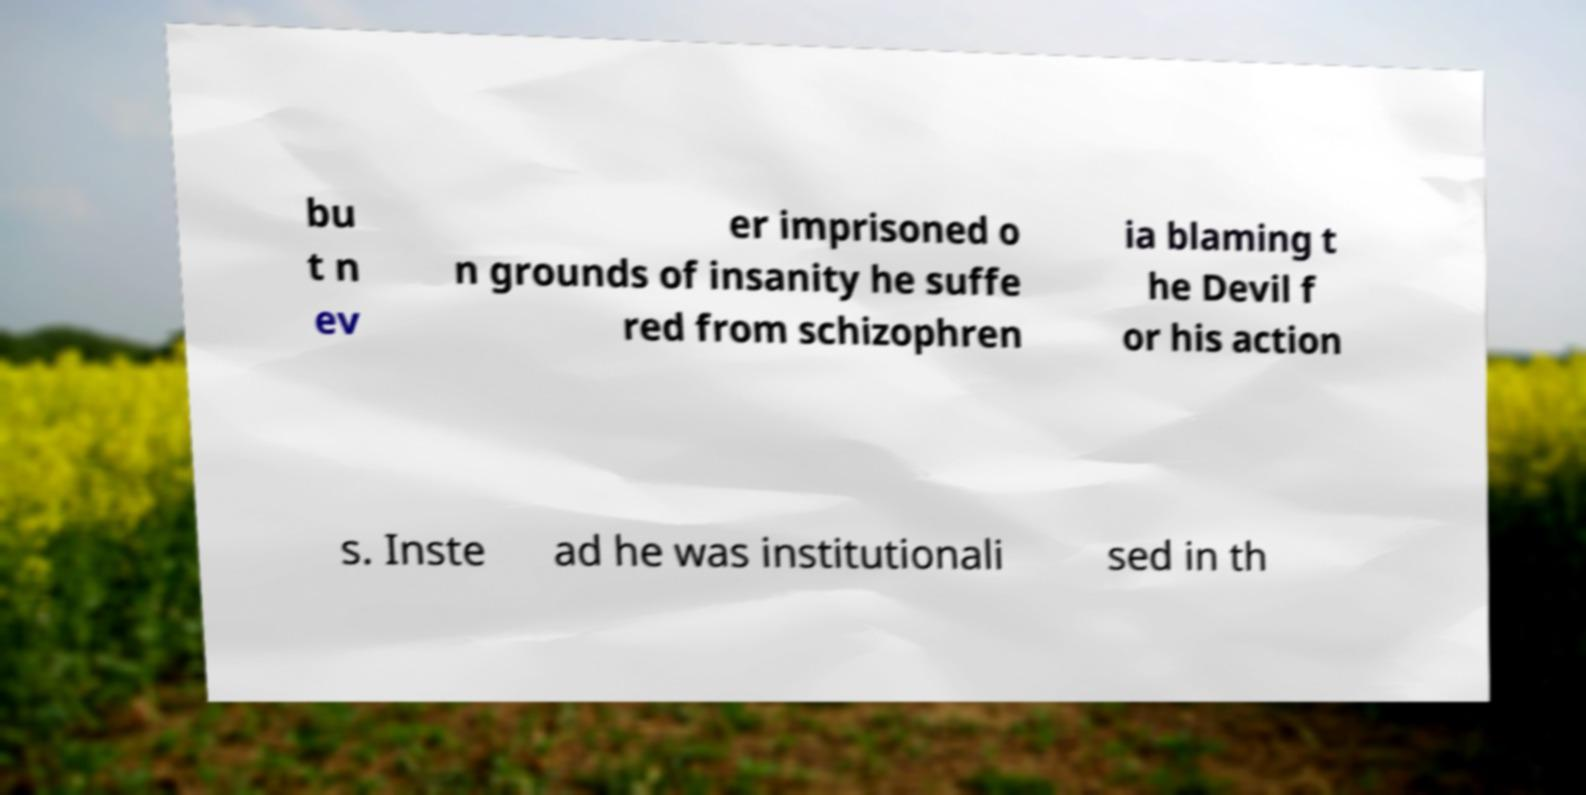For documentation purposes, I need the text within this image transcribed. Could you provide that? bu t n ev er imprisoned o n grounds of insanity he suffe red from schizophren ia blaming t he Devil f or his action s. Inste ad he was institutionali sed in th 